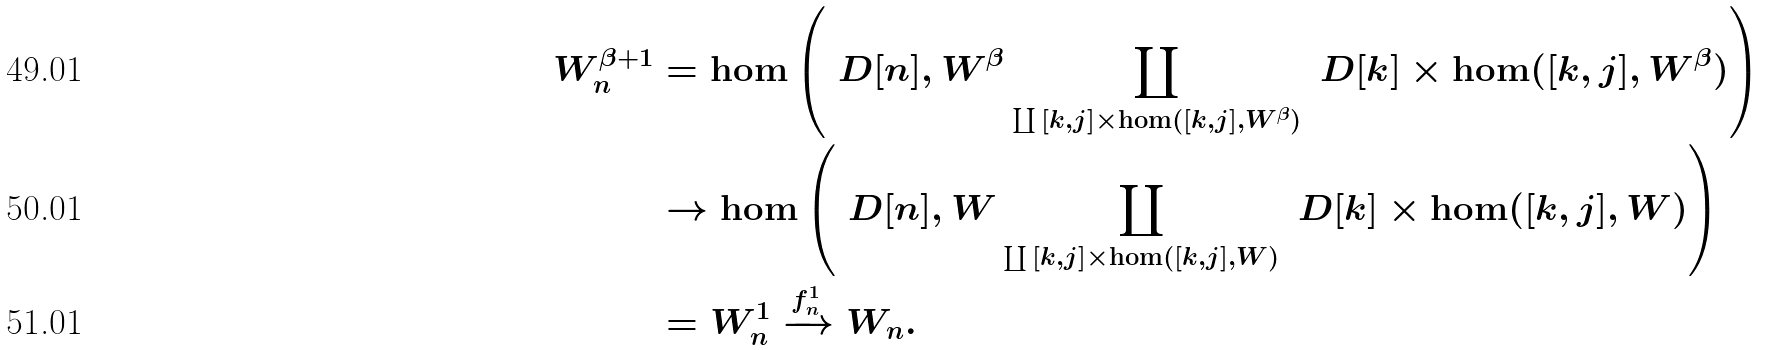Convert formula to latex. <formula><loc_0><loc_0><loc_500><loc_500>W ^ { \beta + 1 } _ { n } & = \hom \left ( \ D [ n ] , W ^ { \beta } \coprod _ { \coprod \L [ k , j ] \times \hom ( \L [ k , j ] , W ^ { \beta } ) } \ D [ k ] \times \hom ( \L [ k , j ] , W ^ { \beta } ) \right ) \\ & \to \hom \left ( \ D [ n ] , W \coprod _ { \coprod \L [ k , j ] \times \hom ( \L [ k , j ] , W ) } \ D [ k ] \times \hom ( \L [ k , j ] , W ) \right ) \\ & = W ^ { 1 } _ { n } \xrightarrow { f ^ { 1 } _ { n } } W _ { n } .</formula> 